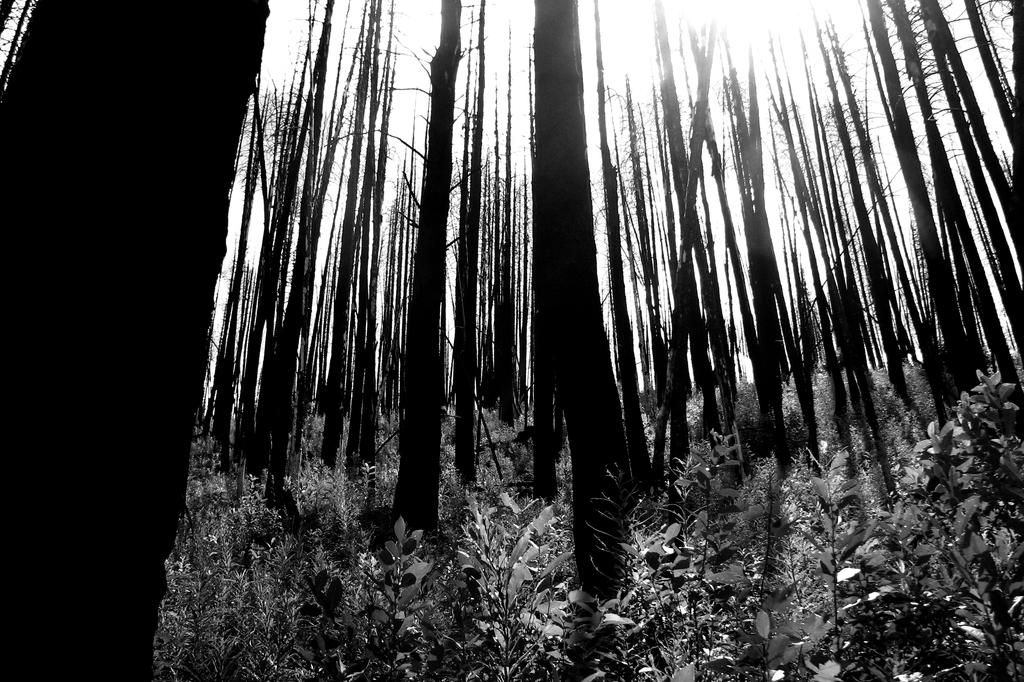What type of vegetation can be seen in the image? There are trees and plants in the image. What is the condition of the sky in the image? The sky is clear and sunny in the image. What is the color scheme of the image? The image is black and white. Where is the hospital located in the image? There is no hospital present in the image. What type of hammer is being used by the church in the image? There is no hammer or church present in the image. 